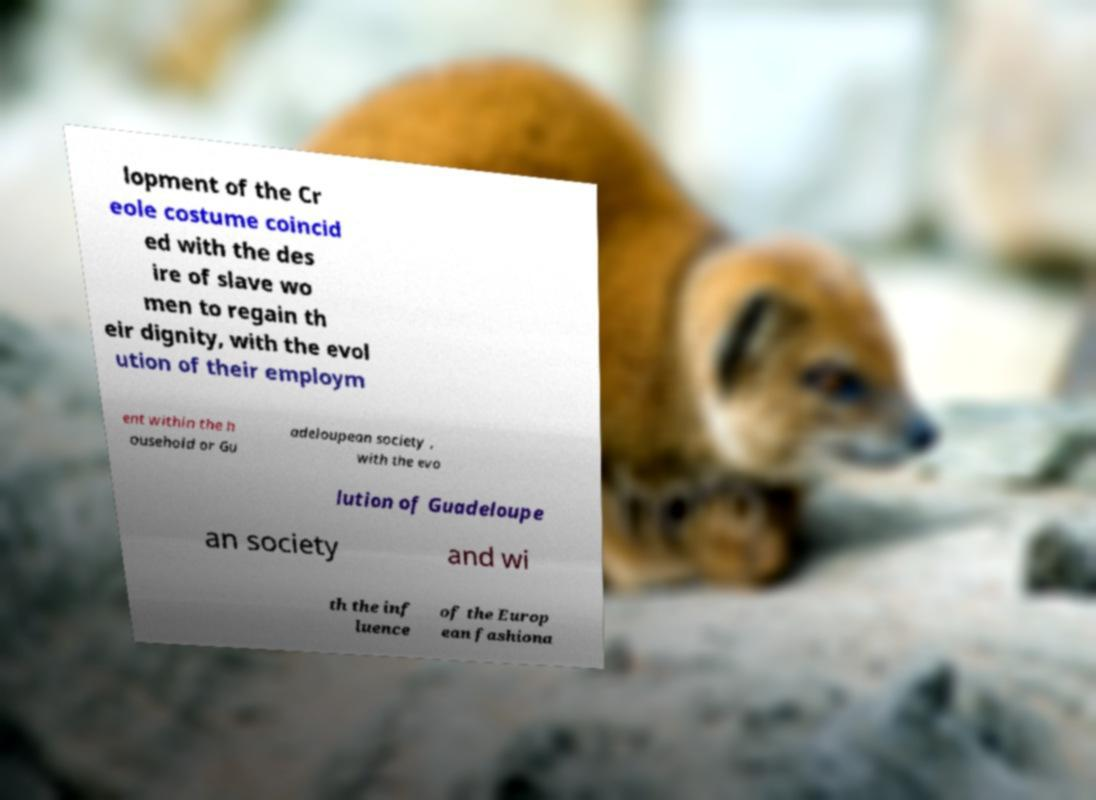Please identify and transcribe the text found in this image. lopment of the Cr eole costume coincid ed with the des ire of slave wo men to regain th eir dignity, with the evol ution of their employm ent within the h ousehold or Gu adeloupean society , with the evo lution of Guadeloupe an society and wi th the inf luence of the Europ ean fashiona 